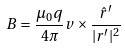Convert formula to latex. <formula><loc_0><loc_0><loc_500><loc_500>B = \frac { \mu _ { 0 } q } { 4 \pi } v \times \frac { \hat { r } ^ { \prime } } { | r ^ { \prime } | ^ { 2 } }</formula> 